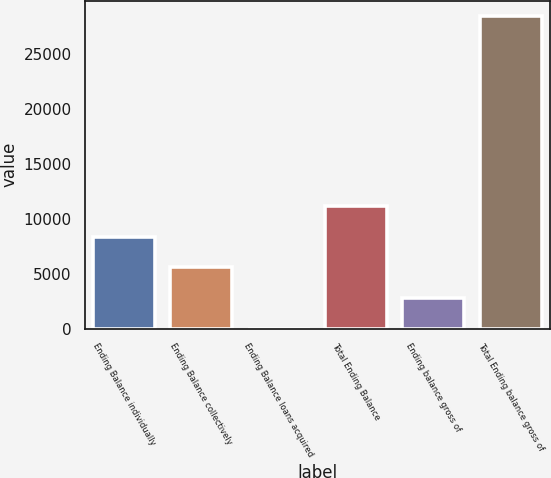Convert chart. <chart><loc_0><loc_0><loc_500><loc_500><bar_chart><fcel>Ending Balance individually<fcel>Ending Balance collectively<fcel>Ending Balance loans acquired<fcel>Total Ending Balance<fcel>Ending balance gross of<fcel>Total Ending balance gross of<nl><fcel>8380.31<fcel>5587.36<fcel>1.46<fcel>11173.3<fcel>2794.41<fcel>28445<nl></chart> 